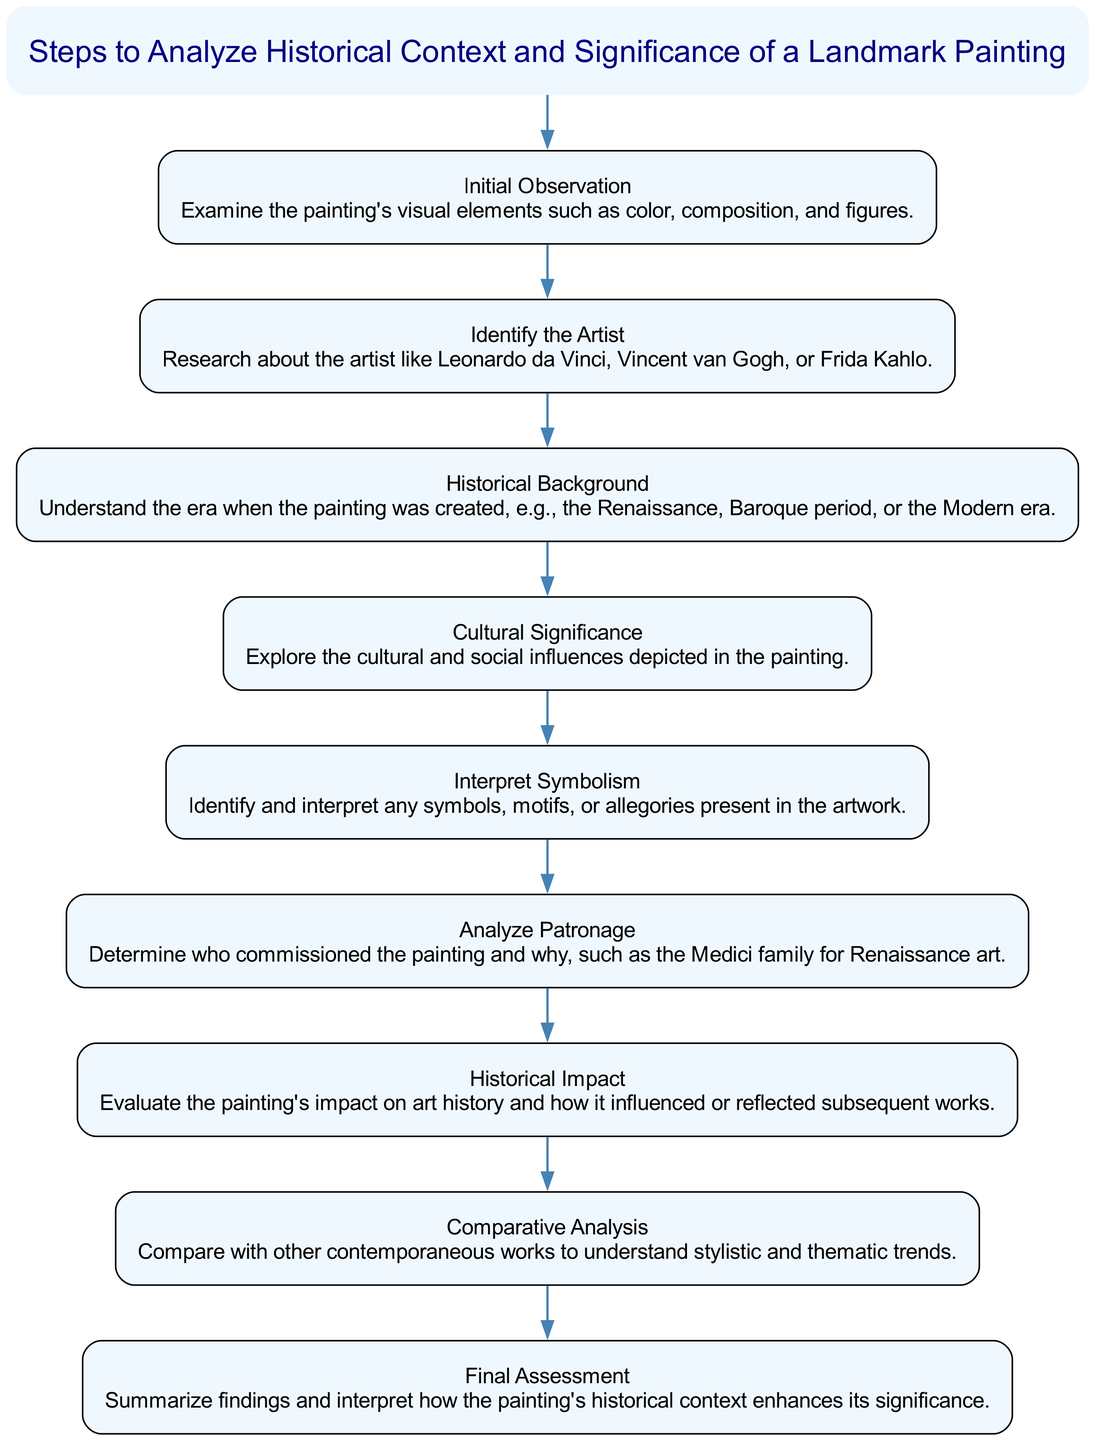What is the title of the diagram? The title node at the top of the diagram clearly states "Steps to Analyze Historical Context and Significance of a Landmark Painting." This is presented in larger font and positioned prominently above all the steps.
Answer: Steps to Analyze Historical Context and Significance of a Landmark Painting How many steps are there in the diagram? By counting all the nodes listed under the title, there are a total of nine steps presented in the diagram. Each step corresponds to a numbered point in the analysis process.
Answer: 9 What is the first step in the flow chart? The first step, represented as the initial node after the title, indicates "Initial Observation." It sets the beginning of the analysis process.
Answer: Initial Observation Which step follows "Cultural Significance"? In the sequence of the flow chart, the node titled "Cultural Significance" directly connects to the subsequent node titled "Interpret Symbolism," indicating the progression of analysis.
Answer: Interpret Symbolism What is the last step listed in the diagram? The final node in the flow chart is "Final Assessment," which is the last stage of the analysis process, summarizing findings.
Answer: Final Assessment Explain how "Historical Background" relates to "Historical Impact." "Historical Background" provides context regarding the era of the painting, which is essential to understand its "Historical Impact." This means that the insights drawn from the background will influence the evaluation of the painting's impact on art history, reflecting a direct connection between these two steps in the diagram's flow.
Answer: They are sequential; background informs impact How does the analysis of symbolism affect the final assessment? The step for "Interpret Symbolism" plays a critical role in understanding the underlying messages of the painting. This detailed interpretation contributes insights that will be utilized in the "Final Assessment," helping to articulate how the painting's historical context enhances its significance. Thus, symbolism is a foundation for the final appraisal.
Answer: Symbolism informs significance What step comes after "Analyze Patronage"? Following "Analyze Patronage," the diagram includes the step titled "Historical Impact." This indicates that evaluating who commissioned the painting precedes assessing its broader historical significance.
Answer: Historical Impact In which step do we investigate the artist of the painting? The step dedicated to researching the artist is explicitly titled "Identify the Artist," which focuses on gathering information about the creator's background and importance in relation to the painting.
Answer: Identify the Artist 